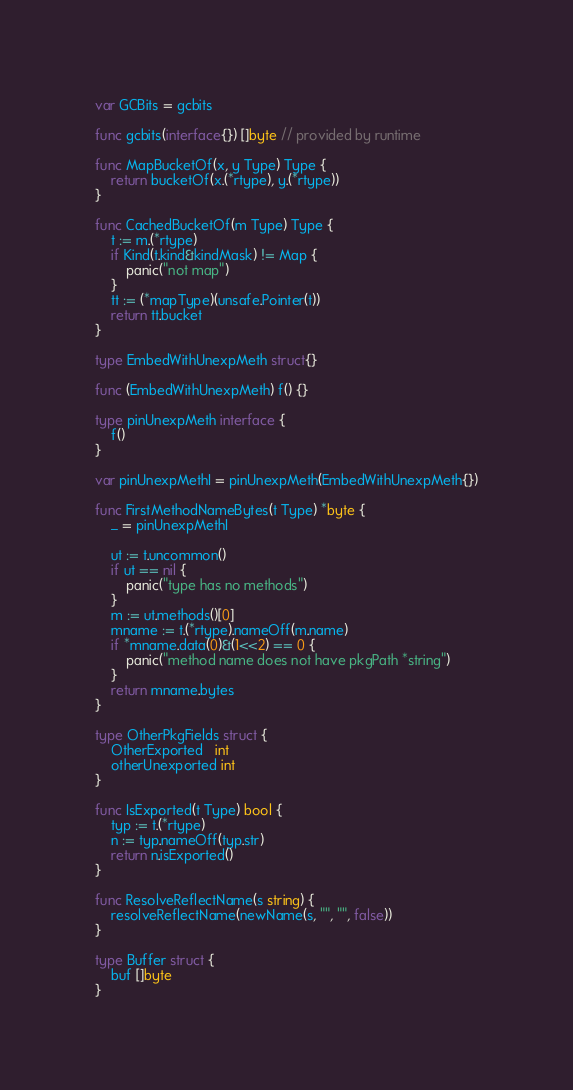Convert code to text. <code><loc_0><loc_0><loc_500><loc_500><_Go_>var GCBits = gcbits

func gcbits(interface{}) []byte // provided by runtime

func MapBucketOf(x, y Type) Type {
	return bucketOf(x.(*rtype), y.(*rtype))
}

func CachedBucketOf(m Type) Type {
	t := m.(*rtype)
	if Kind(t.kind&kindMask) != Map {
		panic("not map")
	}
	tt := (*mapType)(unsafe.Pointer(t))
	return tt.bucket
}

type EmbedWithUnexpMeth struct{}

func (EmbedWithUnexpMeth) f() {}

type pinUnexpMeth interface {
	f()
}

var pinUnexpMethI = pinUnexpMeth(EmbedWithUnexpMeth{})

func FirstMethodNameBytes(t Type) *byte {
	_ = pinUnexpMethI

	ut := t.uncommon()
	if ut == nil {
		panic("type has no methods")
	}
	m := ut.methods()[0]
	mname := t.(*rtype).nameOff(m.name)
	if *mname.data(0)&(1<<2) == 0 {
		panic("method name does not have pkgPath *string")
	}
	return mname.bytes
}

type OtherPkgFields struct {
	OtherExported   int
	otherUnexported int
}

func IsExported(t Type) bool {
	typ := t.(*rtype)
	n := typ.nameOff(typ.str)
	return n.isExported()
}

func ResolveReflectName(s string) {
	resolveReflectName(newName(s, "", "", false))
}

type Buffer struct {
	buf []byte
}
</code> 